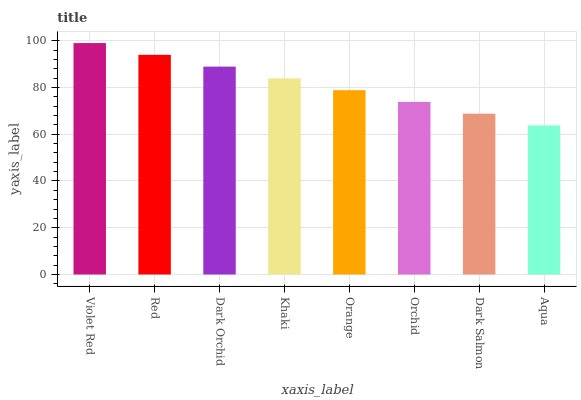Is Aqua the minimum?
Answer yes or no. Yes. Is Violet Red the maximum?
Answer yes or no. Yes. Is Red the minimum?
Answer yes or no. No. Is Red the maximum?
Answer yes or no. No. Is Violet Red greater than Red?
Answer yes or no. Yes. Is Red less than Violet Red?
Answer yes or no. Yes. Is Red greater than Violet Red?
Answer yes or no. No. Is Violet Red less than Red?
Answer yes or no. No. Is Khaki the high median?
Answer yes or no. Yes. Is Orange the low median?
Answer yes or no. Yes. Is Red the high median?
Answer yes or no. No. Is Khaki the low median?
Answer yes or no. No. 